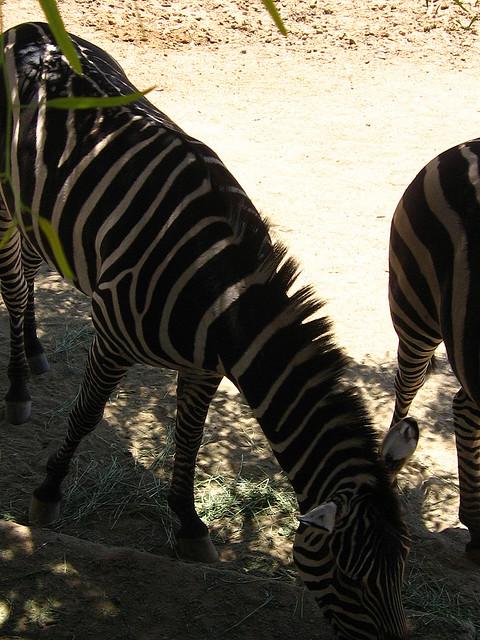What pattern do these animals display?
Concise answer only. Stripes. Do the animals appear to be in captivity?
Quick response, please. Yes. What are the zebras looking for?
Be succinct. Food. 